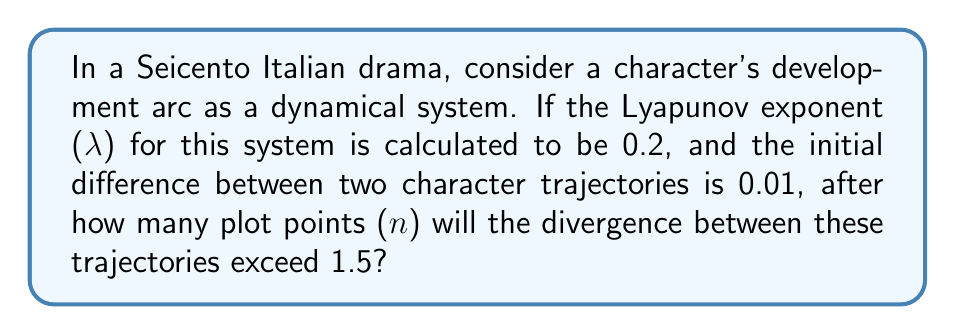Give your solution to this math problem. To solve this problem, we'll use the concept of the Lyapunov exponent in relation to character development arcs in Italian dramas. The Lyapunov exponent measures the rate of divergence of nearby trajectories in a dynamical system.

1) The general formula for the divergence (D) after n iterations is:

   $$D = D_0 e^{\lambda n}$$

   Where $D_0$ is the initial divergence, λ is the Lyapunov exponent, and n is the number of iterations (or plot points in our case).

2) We're given:
   $D_0 = 0.01$ (initial divergence)
   $\lambda = 0.2$ (Lyapunov exponent)
   $D = 1.5$ (final divergence)

3) Substituting these values into the equation:

   $$1.5 = 0.01 e^{0.2n}$$

4) To solve for n, we take the natural logarithm of both sides:

   $$\ln(1.5) = \ln(0.01 e^{0.2n})$$

5) Using the properties of logarithms:

   $$\ln(1.5) = \ln(0.01) + 0.2n$$

6) Solving for n:

   $$0.2n = \ln(1.5) - \ln(0.01)$$
   $$0.2n = 0.4055 + 4.6052 = 5.0107$$

7) Finally:

   $$n = \frac{5.0107}{0.2} = 25.0535$$

8) Since n represents plot points, we need to round up to the nearest whole number.
Answer: 26 plot points 